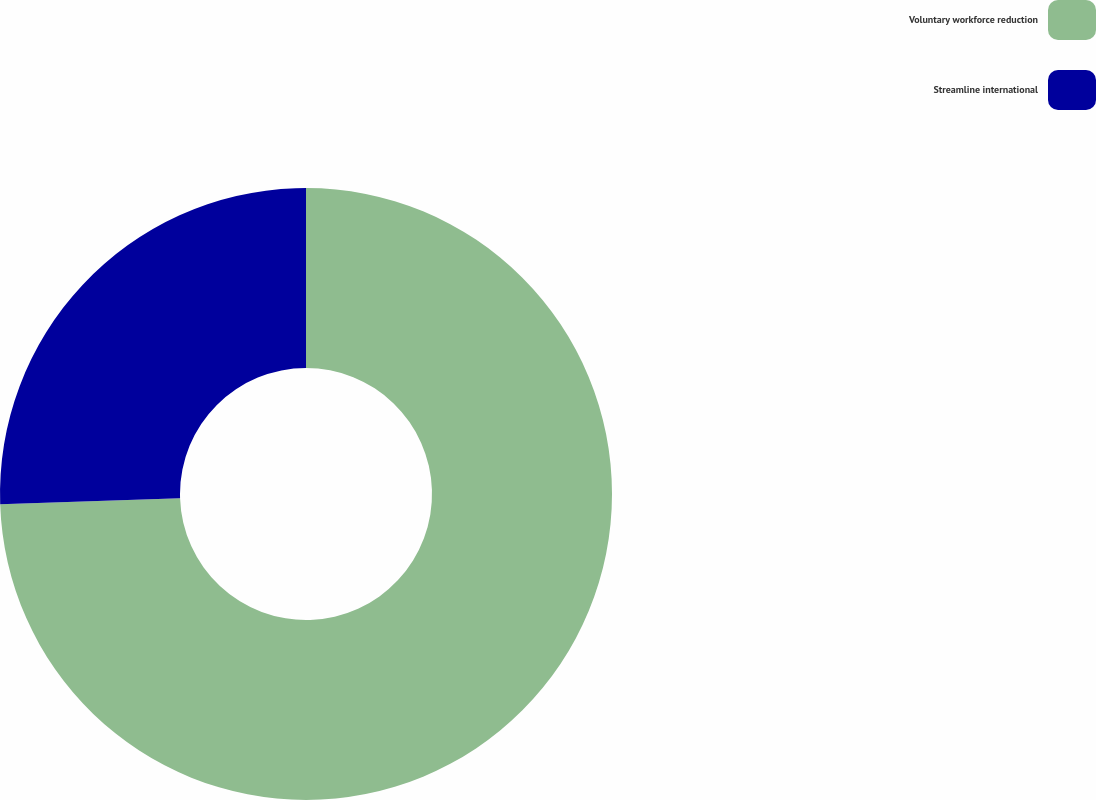<chart> <loc_0><loc_0><loc_500><loc_500><pie_chart><fcel>Voluntary workforce reduction<fcel>Streamline international<nl><fcel>74.47%<fcel>25.53%<nl></chart> 